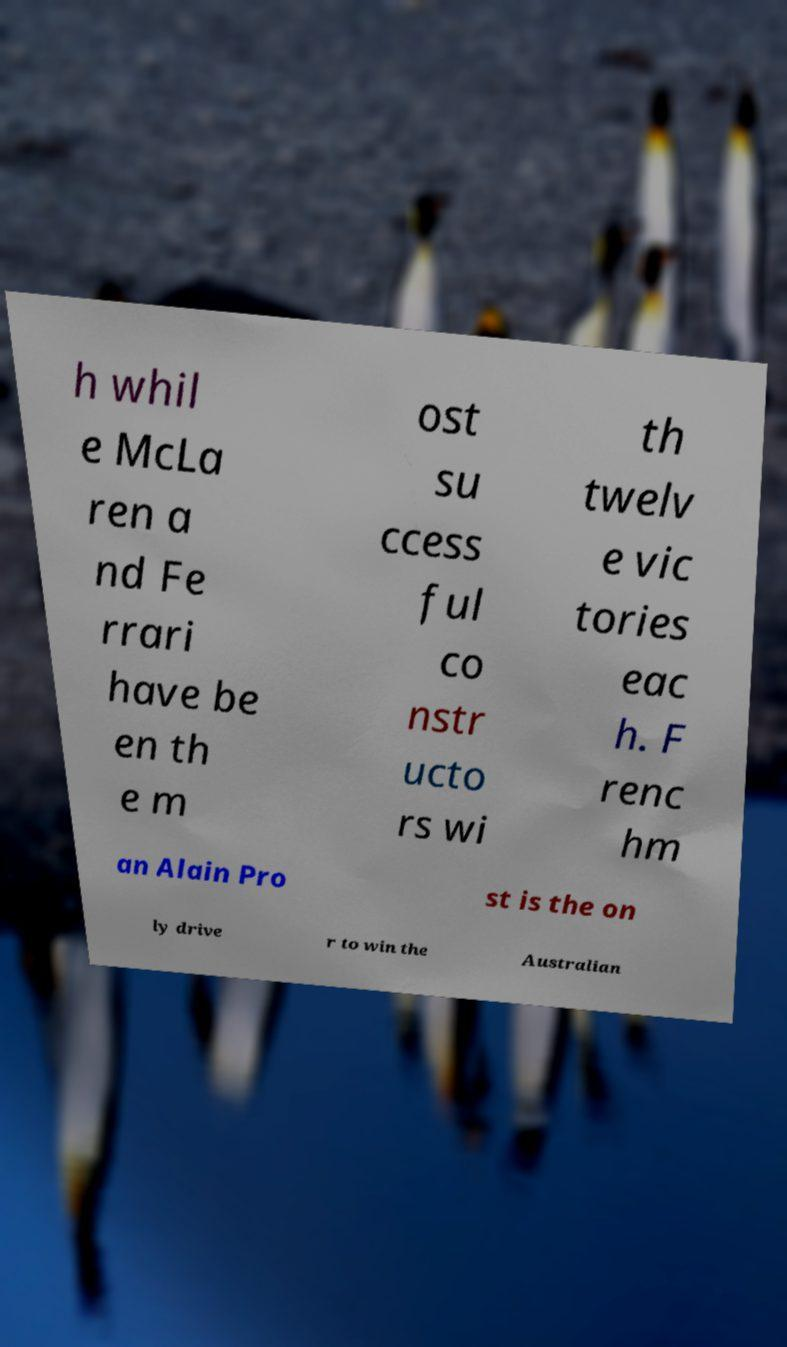Can you read and provide the text displayed in the image?This photo seems to have some interesting text. Can you extract and type it out for me? h whil e McLa ren a nd Fe rrari have be en th e m ost su ccess ful co nstr ucto rs wi th twelv e vic tories eac h. F renc hm an Alain Pro st is the on ly drive r to win the Australian 